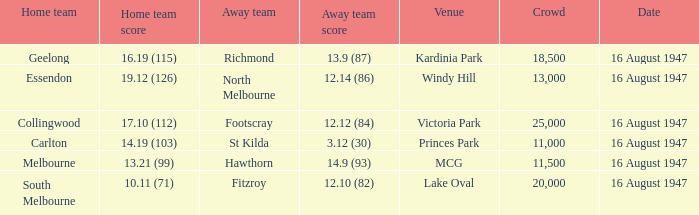How much did the away team score at victoria park? 12.12 (84). 